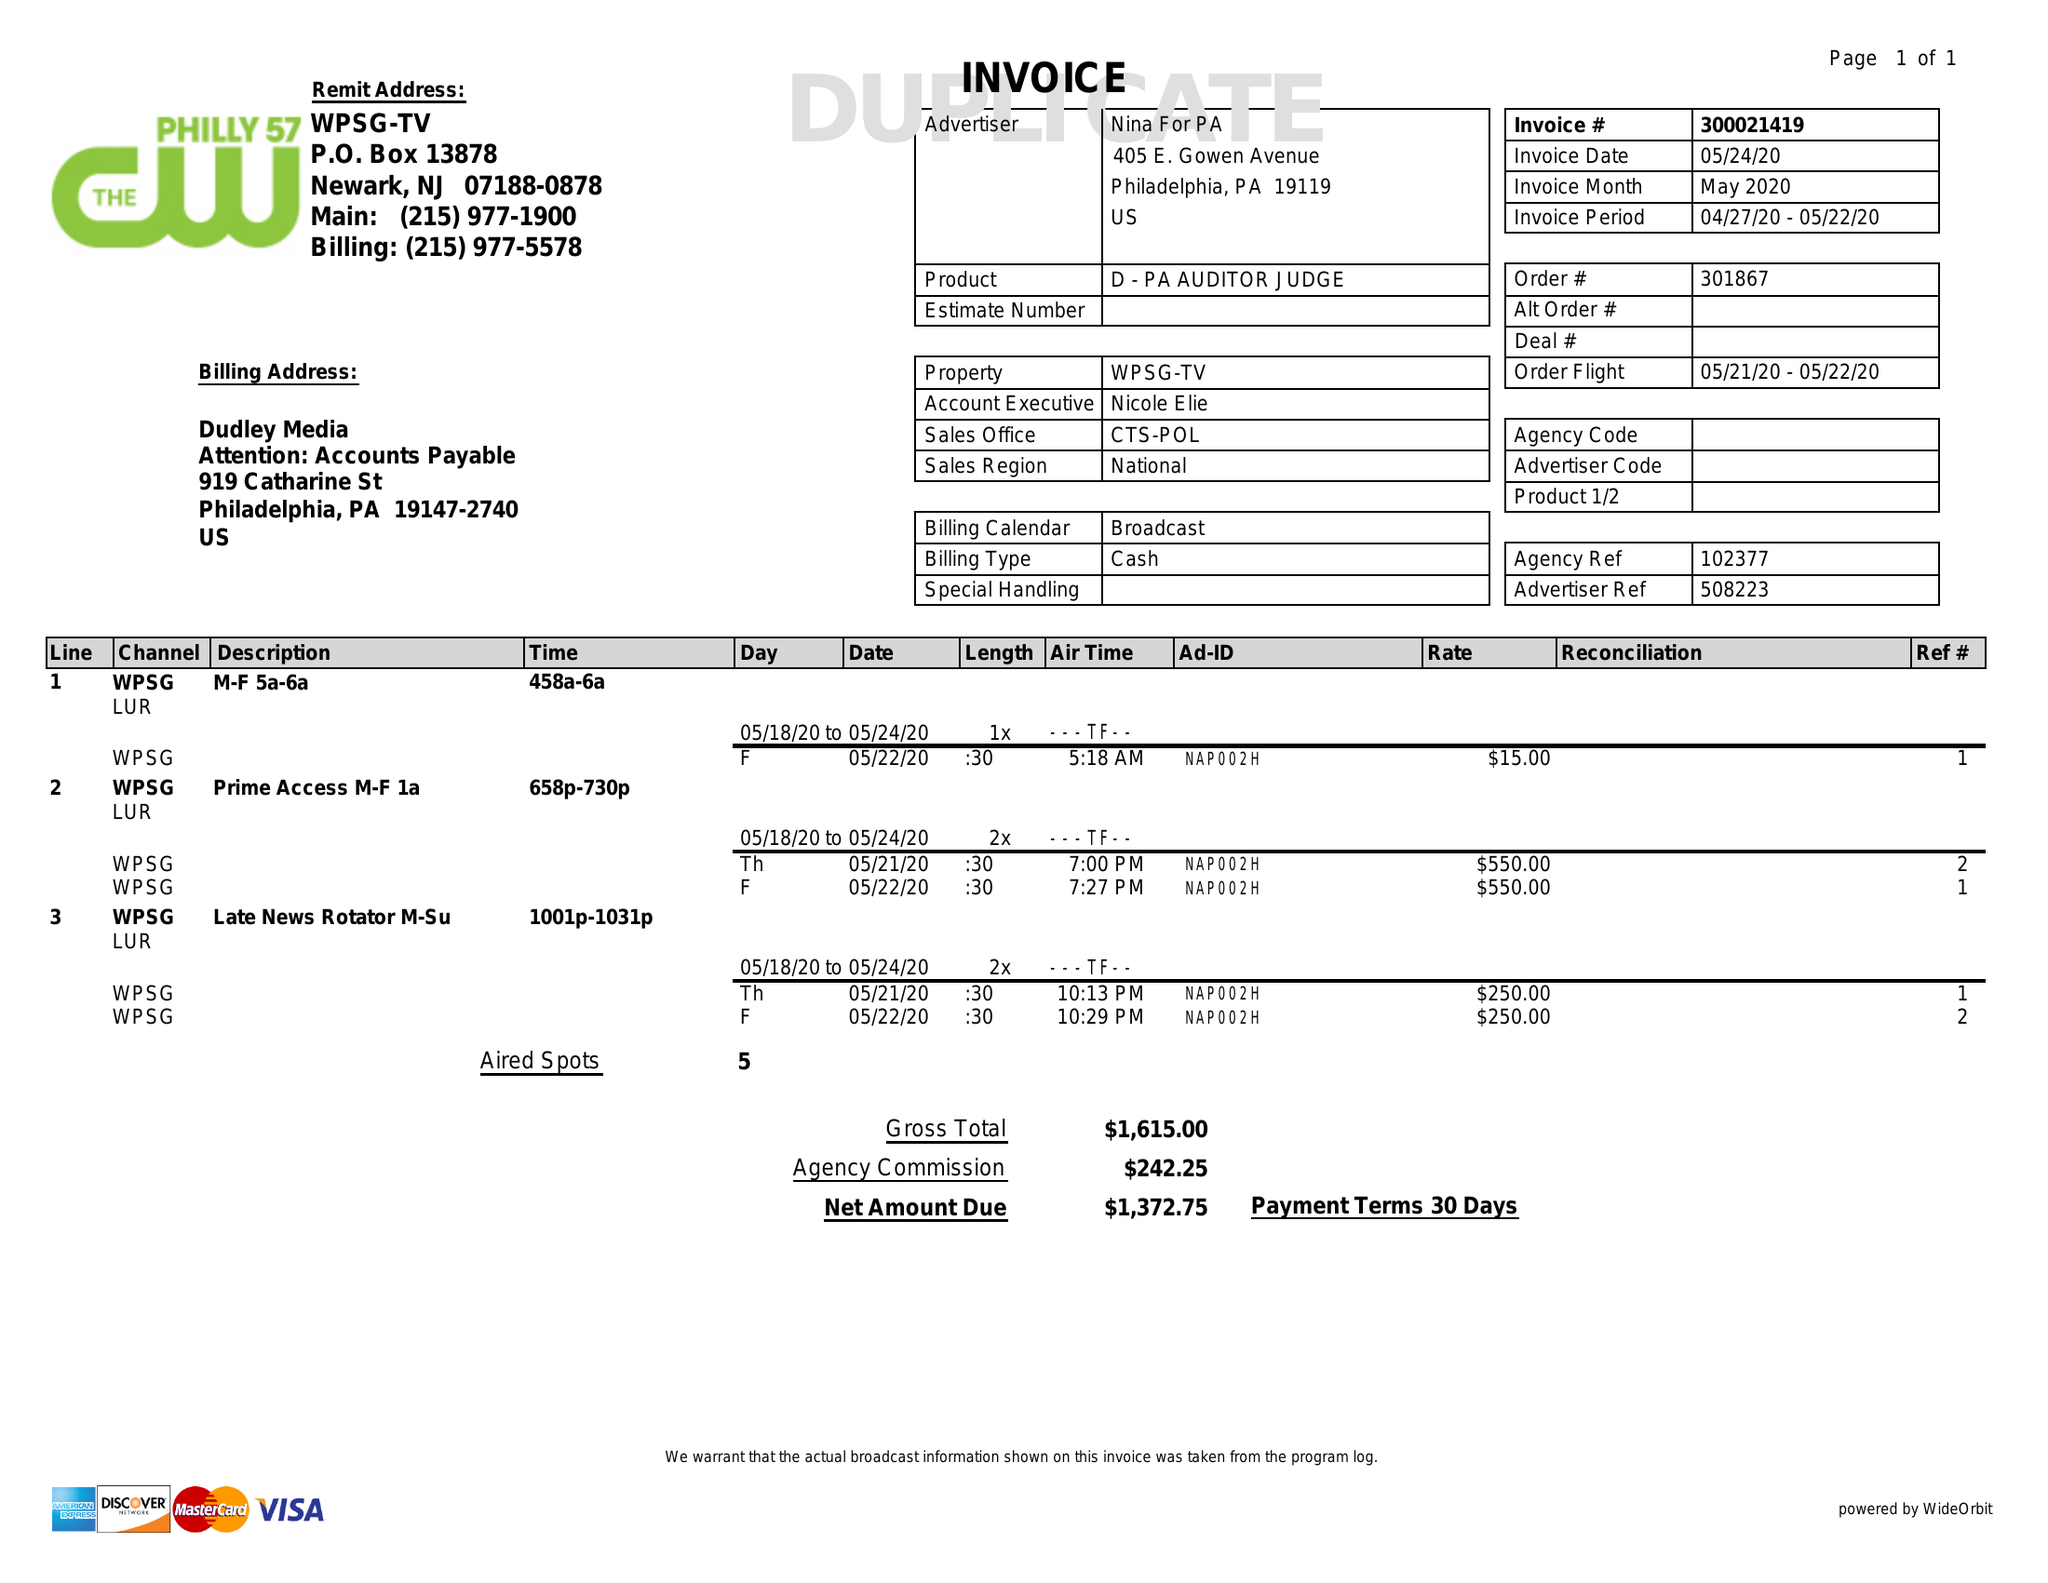What is the value for the contract_num?
Answer the question using a single word or phrase. 300021419 